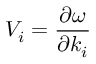Convert formula to latex. <formula><loc_0><loc_0><loc_500><loc_500>V _ { i } = \frac { \partial \omega } { \partial k _ { i } }</formula> 